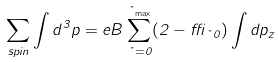Convert formula to latex. <formula><loc_0><loc_0><loc_500><loc_500>\sum _ { s p i n } \int d ^ { 3 } p = e B \sum _ { \nu = 0 } ^ { \nu _ { \max } } ( 2 - \delta _ { \nu { 0 } } ) \int d p _ { z }</formula> 